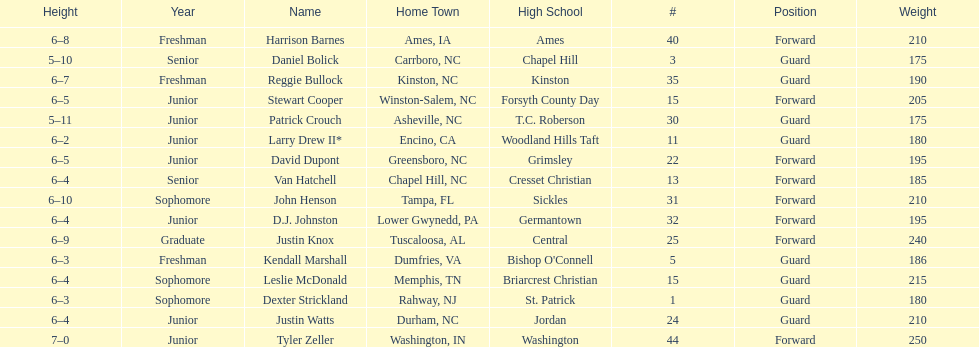How many players are not a junior? 9. 